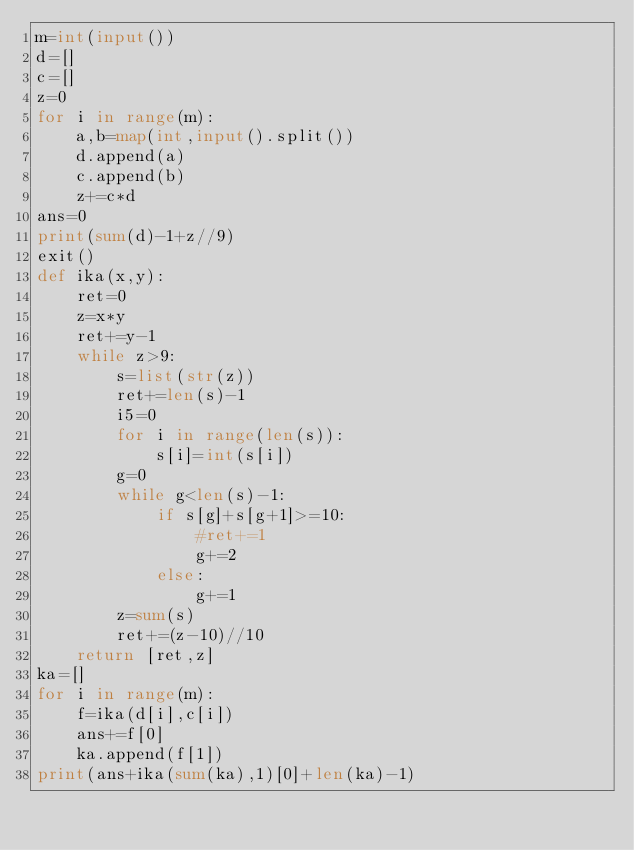<code> <loc_0><loc_0><loc_500><loc_500><_Python_>m=int(input())
d=[]
c=[]
z=0
for i in range(m):
    a,b=map(int,input().split())
    d.append(a)
    c.append(b)
    z+=c*d
ans=0
print(sum(d)-1+z//9)
exit()
def ika(x,y):
    ret=0
    z=x*y
    ret+=y-1
    while z>9:
        s=list(str(z))
        ret+=len(s)-1
        i5=0
        for i in range(len(s)):
            s[i]=int(s[i])
        g=0
        while g<len(s)-1:
            if s[g]+s[g+1]>=10:
                #ret+=1
                g+=2
            else:
                g+=1
        z=sum(s)
        ret+=(z-10)//10
    return [ret,z]
ka=[]
for i in range(m):
    f=ika(d[i],c[i])
    ans+=f[0]
    ka.append(f[1])
print(ans+ika(sum(ka),1)[0]+len(ka)-1)
</code> 